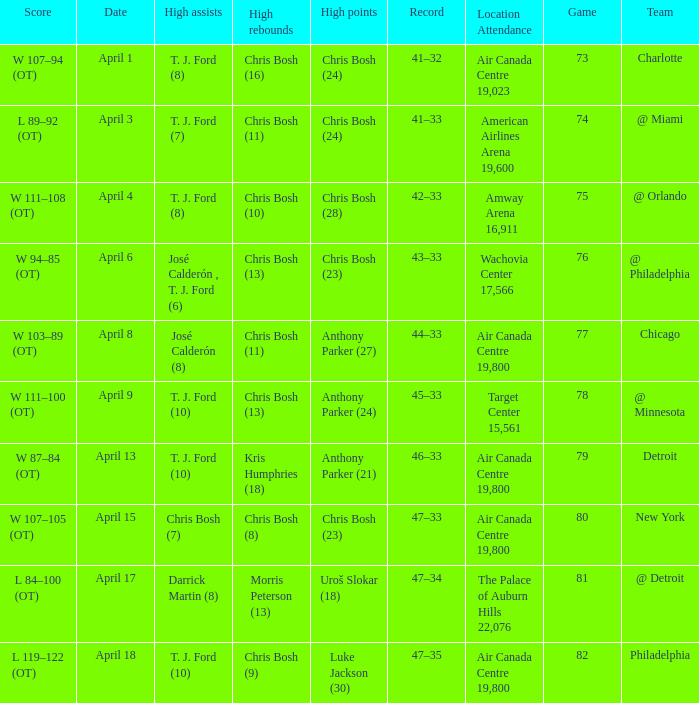What were the assists on April 8 in game less than 78? José Calderón (8). 